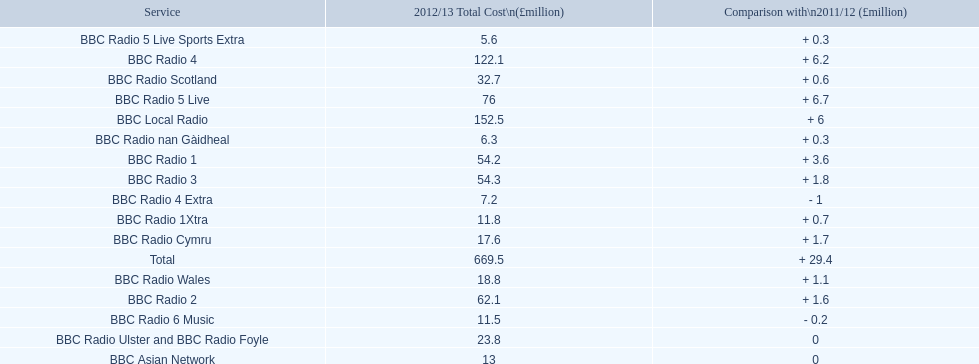What are the bbc stations? BBC Radio 1, BBC Radio 1Xtra, BBC Radio 2, BBC Radio 3, BBC Radio 4, BBC Radio 4 Extra, BBC Radio 5 Live, BBC Radio 5 Live Sports Extra, BBC Radio 6 Music, BBC Asian Network, BBC Local Radio, BBC Radio Scotland, BBC Radio nan Gàidheal, BBC Radio Wales, BBC Radio Cymru, BBC Radio Ulster and BBC Radio Foyle. What was the highest cost to run out of all? 122.1. Which one cost this? BBC Local Radio. 